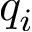Convert formula to latex. <formula><loc_0><loc_0><loc_500><loc_500>q _ { i }</formula> 